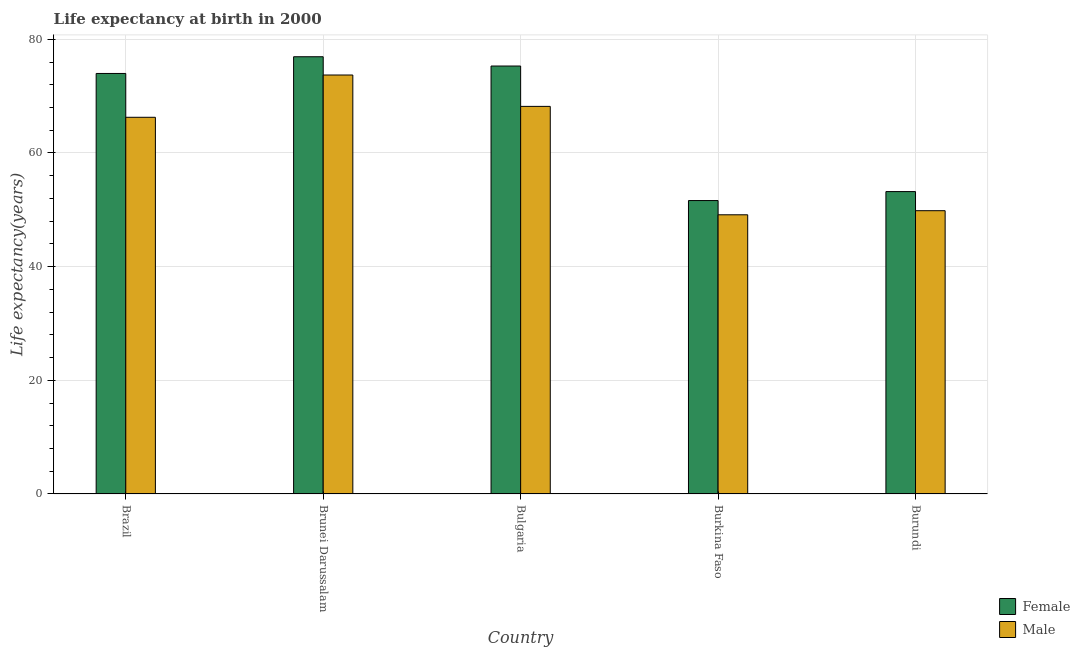Are the number of bars on each tick of the X-axis equal?
Give a very brief answer. Yes. How many bars are there on the 4th tick from the left?
Make the answer very short. 2. What is the label of the 3rd group of bars from the left?
Give a very brief answer. Bulgaria. What is the life expectancy(male) in Burundi?
Provide a short and direct response. 49.84. Across all countries, what is the maximum life expectancy(male)?
Your answer should be very brief. 73.72. Across all countries, what is the minimum life expectancy(male)?
Make the answer very short. 49.12. In which country was the life expectancy(male) maximum?
Your answer should be very brief. Brunei Darussalam. In which country was the life expectancy(female) minimum?
Keep it short and to the point. Burkina Faso. What is the total life expectancy(female) in the graph?
Keep it short and to the point. 331.06. What is the difference between the life expectancy(male) in Burkina Faso and that in Burundi?
Your answer should be very brief. -0.72. What is the difference between the life expectancy(female) in Burkina Faso and the life expectancy(male) in Bulgaria?
Provide a succinct answer. -16.57. What is the average life expectancy(female) per country?
Offer a terse response. 66.21. What is the difference between the life expectancy(male) and life expectancy(female) in Bulgaria?
Provide a succinct answer. -7.1. In how many countries, is the life expectancy(female) greater than 12 years?
Your answer should be very brief. 5. What is the ratio of the life expectancy(male) in Brazil to that in Bulgaria?
Your answer should be compact. 0.97. Is the life expectancy(male) in Brazil less than that in Brunei Darussalam?
Ensure brevity in your answer.  Yes. What is the difference between the highest and the second highest life expectancy(male)?
Keep it short and to the point. 5.52. What is the difference between the highest and the lowest life expectancy(female)?
Give a very brief answer. 25.3. What does the 2nd bar from the right in Brazil represents?
Provide a short and direct response. Female. How many countries are there in the graph?
Your response must be concise. 5. What is the difference between two consecutive major ticks on the Y-axis?
Your response must be concise. 20. Does the graph contain any zero values?
Offer a terse response. No. Does the graph contain grids?
Make the answer very short. Yes. How many legend labels are there?
Provide a short and direct response. 2. What is the title of the graph?
Your response must be concise. Life expectancy at birth in 2000. What is the label or title of the Y-axis?
Provide a succinct answer. Life expectancy(years). What is the Life expectancy(years) in Female in Brazil?
Ensure brevity in your answer.  73.99. What is the Life expectancy(years) in Male in Brazil?
Provide a short and direct response. 66.28. What is the Life expectancy(years) in Female in Brunei Darussalam?
Offer a very short reply. 76.94. What is the Life expectancy(years) in Male in Brunei Darussalam?
Your response must be concise. 73.72. What is the Life expectancy(years) of Female in Bulgaria?
Keep it short and to the point. 75.3. What is the Life expectancy(years) of Male in Bulgaria?
Give a very brief answer. 68.2. What is the Life expectancy(years) in Female in Burkina Faso?
Provide a succinct answer. 51.63. What is the Life expectancy(years) of Male in Burkina Faso?
Give a very brief answer. 49.12. What is the Life expectancy(years) of Female in Burundi?
Your answer should be very brief. 53.21. What is the Life expectancy(years) of Male in Burundi?
Offer a terse response. 49.84. Across all countries, what is the maximum Life expectancy(years) of Female?
Give a very brief answer. 76.94. Across all countries, what is the maximum Life expectancy(years) of Male?
Your response must be concise. 73.72. Across all countries, what is the minimum Life expectancy(years) in Female?
Offer a terse response. 51.63. Across all countries, what is the minimum Life expectancy(years) of Male?
Provide a succinct answer. 49.12. What is the total Life expectancy(years) of Female in the graph?
Ensure brevity in your answer.  331.06. What is the total Life expectancy(years) in Male in the graph?
Provide a short and direct response. 307.17. What is the difference between the Life expectancy(years) of Female in Brazil and that in Brunei Darussalam?
Provide a succinct answer. -2.94. What is the difference between the Life expectancy(years) of Male in Brazil and that in Brunei Darussalam?
Your answer should be very brief. -7.44. What is the difference between the Life expectancy(years) of Female in Brazil and that in Bulgaria?
Your answer should be very brief. -1.31. What is the difference between the Life expectancy(years) of Male in Brazil and that in Bulgaria?
Provide a succinct answer. -1.92. What is the difference between the Life expectancy(years) in Female in Brazil and that in Burkina Faso?
Offer a terse response. 22.36. What is the difference between the Life expectancy(years) of Male in Brazil and that in Burkina Faso?
Keep it short and to the point. 17.16. What is the difference between the Life expectancy(years) in Female in Brazil and that in Burundi?
Give a very brief answer. 20.78. What is the difference between the Life expectancy(years) of Male in Brazil and that in Burundi?
Ensure brevity in your answer.  16.44. What is the difference between the Life expectancy(years) of Female in Brunei Darussalam and that in Bulgaria?
Provide a succinct answer. 1.64. What is the difference between the Life expectancy(years) in Male in Brunei Darussalam and that in Bulgaria?
Your answer should be compact. 5.52. What is the difference between the Life expectancy(years) of Female in Brunei Darussalam and that in Burkina Faso?
Keep it short and to the point. 25.3. What is the difference between the Life expectancy(years) of Male in Brunei Darussalam and that in Burkina Faso?
Give a very brief answer. 24.6. What is the difference between the Life expectancy(years) of Female in Brunei Darussalam and that in Burundi?
Offer a terse response. 23.73. What is the difference between the Life expectancy(years) in Male in Brunei Darussalam and that in Burundi?
Give a very brief answer. 23.88. What is the difference between the Life expectancy(years) in Female in Bulgaria and that in Burkina Faso?
Provide a short and direct response. 23.67. What is the difference between the Life expectancy(years) in Male in Bulgaria and that in Burkina Faso?
Offer a very short reply. 19.08. What is the difference between the Life expectancy(years) of Female in Bulgaria and that in Burundi?
Offer a terse response. 22.09. What is the difference between the Life expectancy(years) of Male in Bulgaria and that in Burundi?
Offer a terse response. 18.36. What is the difference between the Life expectancy(years) of Female in Burkina Faso and that in Burundi?
Your answer should be very brief. -1.58. What is the difference between the Life expectancy(years) in Male in Burkina Faso and that in Burundi?
Offer a terse response. -0.72. What is the difference between the Life expectancy(years) of Female in Brazil and the Life expectancy(years) of Male in Brunei Darussalam?
Provide a succinct answer. 0.27. What is the difference between the Life expectancy(years) in Female in Brazil and the Life expectancy(years) in Male in Bulgaria?
Your answer should be very brief. 5.79. What is the difference between the Life expectancy(years) of Female in Brazil and the Life expectancy(years) of Male in Burkina Faso?
Keep it short and to the point. 24.87. What is the difference between the Life expectancy(years) of Female in Brazil and the Life expectancy(years) of Male in Burundi?
Give a very brief answer. 24.15. What is the difference between the Life expectancy(years) of Female in Brunei Darussalam and the Life expectancy(years) of Male in Bulgaria?
Your answer should be very brief. 8.73. What is the difference between the Life expectancy(years) in Female in Brunei Darussalam and the Life expectancy(years) in Male in Burkina Faso?
Your answer should be very brief. 27.81. What is the difference between the Life expectancy(years) in Female in Brunei Darussalam and the Life expectancy(years) in Male in Burundi?
Provide a short and direct response. 27.09. What is the difference between the Life expectancy(years) of Female in Bulgaria and the Life expectancy(years) of Male in Burkina Faso?
Make the answer very short. 26.18. What is the difference between the Life expectancy(years) in Female in Bulgaria and the Life expectancy(years) in Male in Burundi?
Provide a succinct answer. 25.45. What is the difference between the Life expectancy(years) of Female in Burkina Faso and the Life expectancy(years) of Male in Burundi?
Ensure brevity in your answer.  1.78. What is the average Life expectancy(years) of Female per country?
Make the answer very short. 66.21. What is the average Life expectancy(years) in Male per country?
Your response must be concise. 61.43. What is the difference between the Life expectancy(years) in Female and Life expectancy(years) in Male in Brazil?
Keep it short and to the point. 7.71. What is the difference between the Life expectancy(years) in Female and Life expectancy(years) in Male in Brunei Darussalam?
Provide a succinct answer. 3.21. What is the difference between the Life expectancy(years) of Female and Life expectancy(years) of Male in Burkina Faso?
Give a very brief answer. 2.51. What is the difference between the Life expectancy(years) in Female and Life expectancy(years) in Male in Burundi?
Provide a succinct answer. 3.36. What is the ratio of the Life expectancy(years) in Female in Brazil to that in Brunei Darussalam?
Your answer should be compact. 0.96. What is the ratio of the Life expectancy(years) of Male in Brazil to that in Brunei Darussalam?
Provide a succinct answer. 0.9. What is the ratio of the Life expectancy(years) in Female in Brazil to that in Bulgaria?
Your answer should be very brief. 0.98. What is the ratio of the Life expectancy(years) in Male in Brazil to that in Bulgaria?
Ensure brevity in your answer.  0.97. What is the ratio of the Life expectancy(years) in Female in Brazil to that in Burkina Faso?
Ensure brevity in your answer.  1.43. What is the ratio of the Life expectancy(years) of Male in Brazil to that in Burkina Faso?
Your answer should be very brief. 1.35. What is the ratio of the Life expectancy(years) in Female in Brazil to that in Burundi?
Offer a terse response. 1.39. What is the ratio of the Life expectancy(years) in Male in Brazil to that in Burundi?
Provide a succinct answer. 1.33. What is the ratio of the Life expectancy(years) in Female in Brunei Darussalam to that in Bulgaria?
Your response must be concise. 1.02. What is the ratio of the Life expectancy(years) of Male in Brunei Darussalam to that in Bulgaria?
Keep it short and to the point. 1.08. What is the ratio of the Life expectancy(years) in Female in Brunei Darussalam to that in Burkina Faso?
Provide a succinct answer. 1.49. What is the ratio of the Life expectancy(years) of Male in Brunei Darussalam to that in Burkina Faso?
Your answer should be compact. 1.5. What is the ratio of the Life expectancy(years) in Female in Brunei Darussalam to that in Burundi?
Your answer should be compact. 1.45. What is the ratio of the Life expectancy(years) in Male in Brunei Darussalam to that in Burundi?
Ensure brevity in your answer.  1.48. What is the ratio of the Life expectancy(years) in Female in Bulgaria to that in Burkina Faso?
Keep it short and to the point. 1.46. What is the ratio of the Life expectancy(years) of Male in Bulgaria to that in Burkina Faso?
Your response must be concise. 1.39. What is the ratio of the Life expectancy(years) in Female in Bulgaria to that in Burundi?
Make the answer very short. 1.42. What is the ratio of the Life expectancy(years) in Male in Bulgaria to that in Burundi?
Your answer should be compact. 1.37. What is the ratio of the Life expectancy(years) in Female in Burkina Faso to that in Burundi?
Your response must be concise. 0.97. What is the ratio of the Life expectancy(years) of Male in Burkina Faso to that in Burundi?
Offer a very short reply. 0.99. What is the difference between the highest and the second highest Life expectancy(years) of Female?
Your answer should be compact. 1.64. What is the difference between the highest and the second highest Life expectancy(years) of Male?
Give a very brief answer. 5.52. What is the difference between the highest and the lowest Life expectancy(years) in Female?
Give a very brief answer. 25.3. What is the difference between the highest and the lowest Life expectancy(years) in Male?
Ensure brevity in your answer.  24.6. 